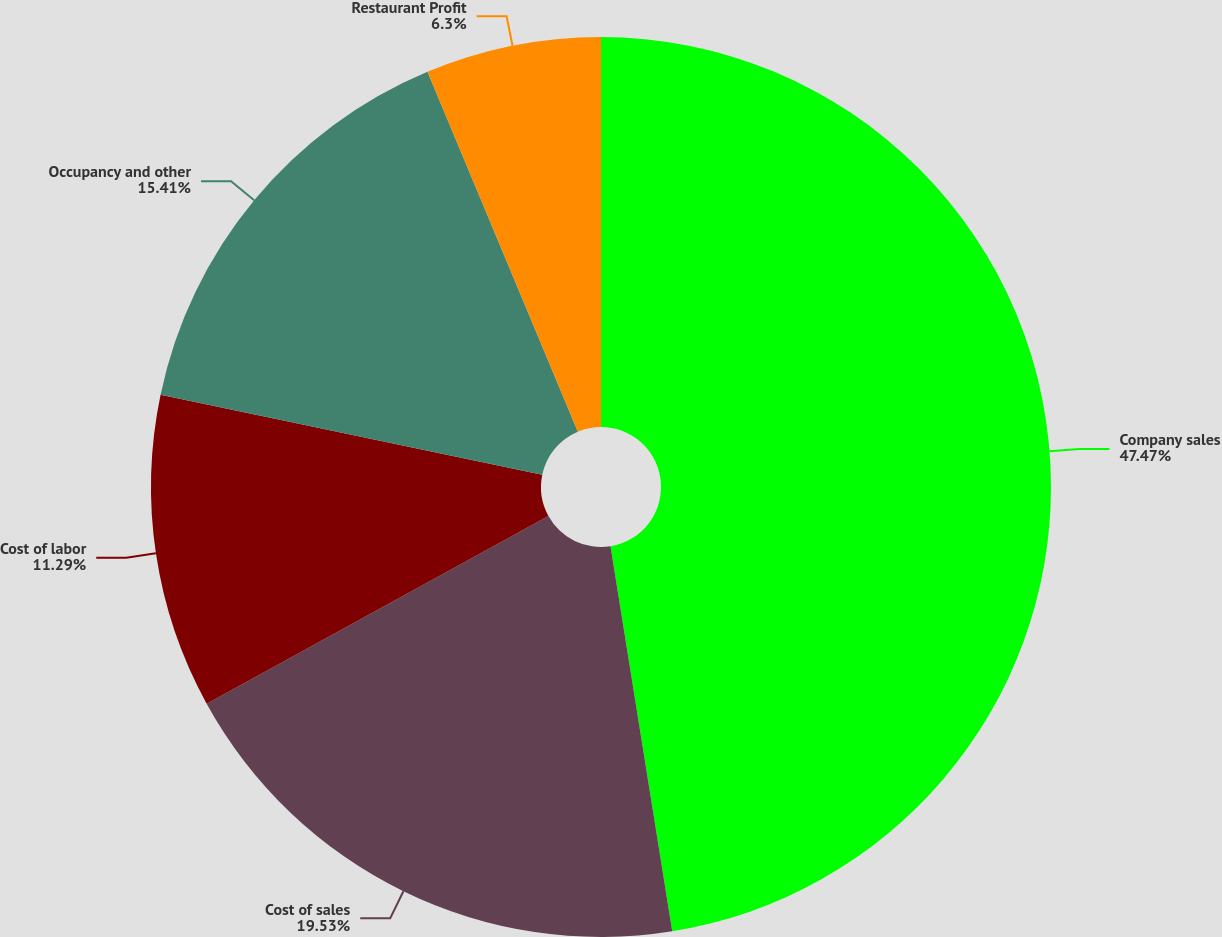<chart> <loc_0><loc_0><loc_500><loc_500><pie_chart><fcel>Company sales<fcel>Cost of sales<fcel>Cost of labor<fcel>Occupancy and other<fcel>Restaurant Profit<nl><fcel>47.47%<fcel>19.53%<fcel>11.29%<fcel>15.41%<fcel>6.3%<nl></chart> 